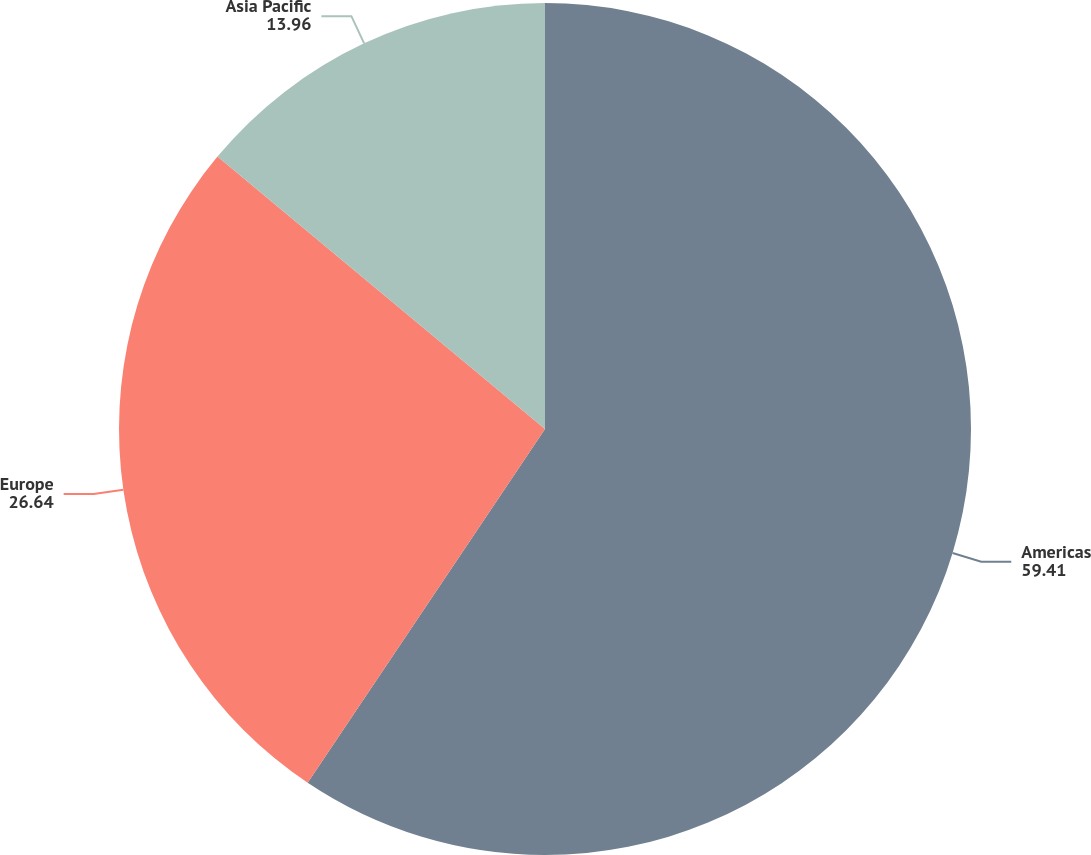<chart> <loc_0><loc_0><loc_500><loc_500><pie_chart><fcel>Americas<fcel>Europe<fcel>Asia Pacific<nl><fcel>59.41%<fcel>26.64%<fcel>13.96%<nl></chart> 